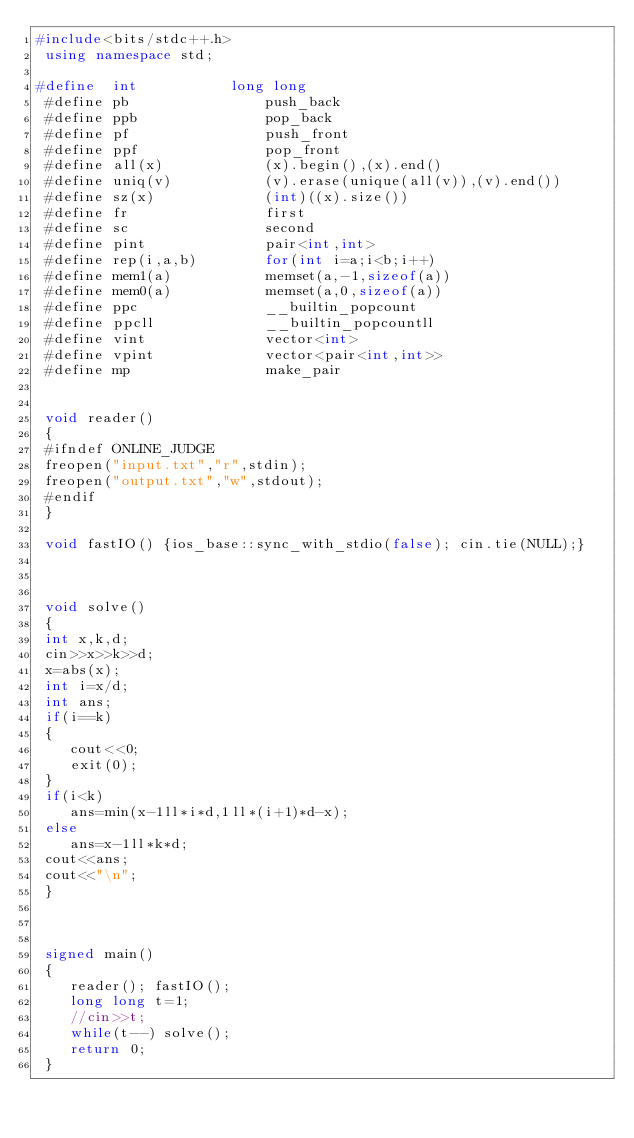Convert code to text. <code><loc_0><loc_0><loc_500><loc_500><_C++_>#include<bits/stdc++.h>
 using namespace std;
 
#define  int           long long
 #define pb                push_back
 #define ppb               pop_back
 #define pf                push_front
 #define ppf               pop_front
 #define all(x)            (x).begin(),(x).end()
 #define uniq(v)           (v).erase(unique(all(v)),(v).end())
 #define sz(x)             (int)((x).size())
 #define fr                first
 #define sc                second
 #define pint              pair<int,int>
 #define rep(i,a,b)        for(int i=a;i<b;i++)
 #define mem1(a)           memset(a,-1,sizeof(a))
 #define mem0(a)           memset(a,0,sizeof(a))
 #define ppc               __builtin_popcount
 #define ppcll             __builtin_popcountll
 #define vint			   vector<int>
 #define vpint			   vector<pair<int,int>>
 #define mp                make_pair


 void reader() 
 { 
 #ifndef ONLINE_JUDGE 
 freopen("input.txt","r",stdin);
 freopen("output.txt","w",stdout); 
 #endif
 }
 
 void fastIO() {ios_base::sync_with_stdio(false); cin.tie(NULL);}
 
 
 
 void solve()
 {
 int x,k,d;
 cin>>x>>k>>d;
 x=abs(x);
 int i=x/d;
 int ans;
 if(i==k)
 {
 	cout<<0;
 	exit(0);
 }
 if(i<k)
 	ans=min(x-1ll*i*d,1ll*(i+1)*d-x);
 else
 	ans=x-1ll*k*d;
 cout<<ans;
 cout<<"\n";
 }
 
 
 
 signed main()
 {
 	reader(); fastIO();
 	long long t=1;
 	//cin>>t;
 	while(t--) solve();
 	return 0;
 }</code> 